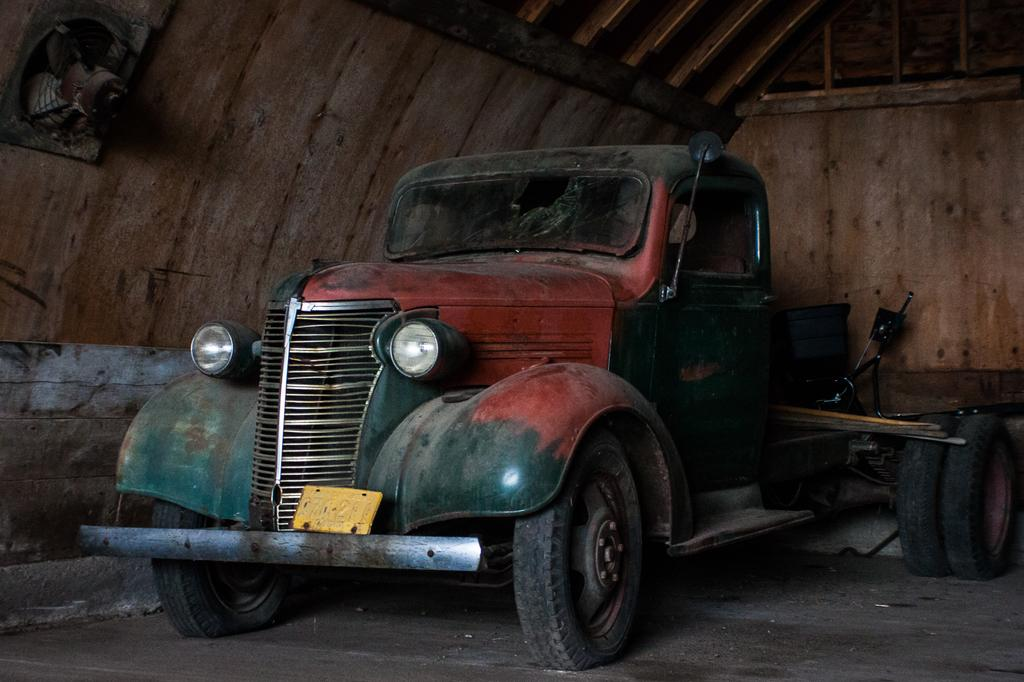What is the main subject of the image? There is a vehicle in the image. What else can be seen in the image besides the vehicle? There are objects and a wooden shed in the image. What feature is attached to the wooden shed? An exhaust-fan is attached to the shed. What type of paper is being used to cover the vehicle in the image? There is no paper covering the vehicle in the image. 